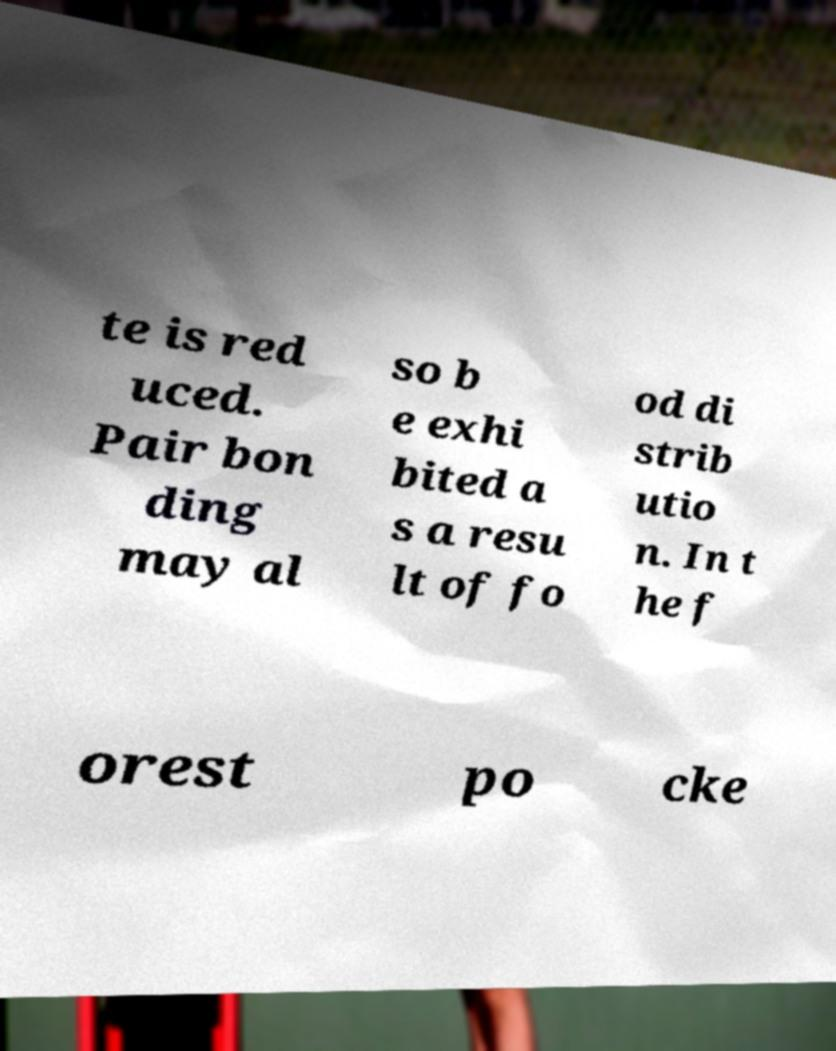Please read and relay the text visible in this image. What does it say? te is red uced. Pair bon ding may al so b e exhi bited a s a resu lt of fo od di strib utio n. In t he f orest po cke 